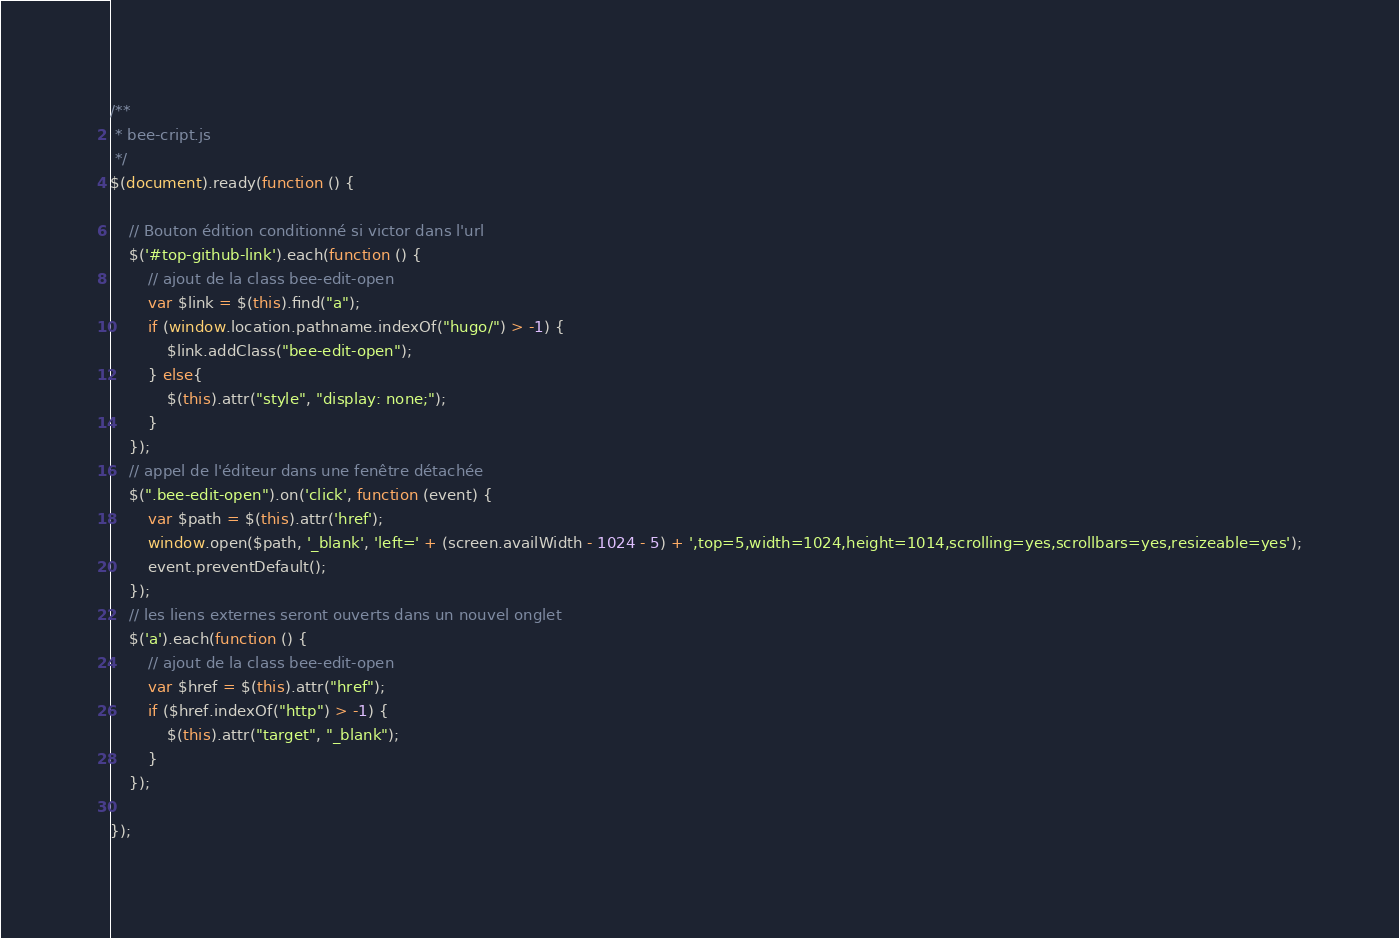Convert code to text. <code><loc_0><loc_0><loc_500><loc_500><_JavaScript_>/**
 * bee-cript.js
 */
$(document).ready(function () {

    // Bouton édition conditionné si victor dans l'url
    $('#top-github-link').each(function () {
        // ajout de la class bee-edit-open
        var $link = $(this).find("a");
        if (window.location.pathname.indexOf("hugo/") > -1) {
            $link.addClass("bee-edit-open");
        } else{
            $(this).attr("style", "display: none;");
        }
    });
    // appel de l'éditeur dans une fenêtre détachée
    $(".bee-edit-open").on('click', function (event) {
        var $path = $(this).attr('href');
        window.open($path, '_blank', 'left=' + (screen.availWidth - 1024 - 5) + ',top=5,width=1024,height=1014,scrolling=yes,scrollbars=yes,resizeable=yes');
        event.preventDefault();
    });
    // les liens externes seront ouverts dans un nouvel onglet
    $('a').each(function () {
        // ajout de la class bee-edit-open
        var $href = $(this).attr("href");
        if ($href.indexOf("http") > -1) {
            $(this).attr("target", "_blank");
        }
    });

});</code> 